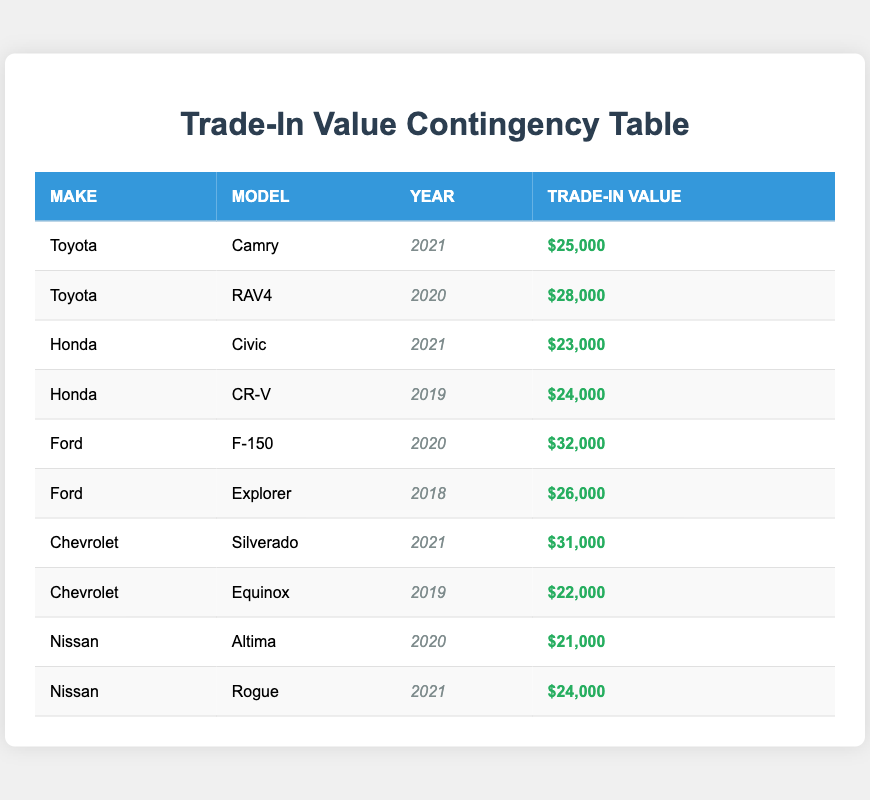What is the trade-in value of the Toyota Camry? Looking at the table, the trade-in value for the Toyota Camry, listed as a 2021 model, is clearly stated as $25,000.
Answer: $25,000 Which vehicle has the highest trade-in value? The table lists the trade-in values of various vehicles; the highest value is for the Ford F-150 at $32,000.
Answer: Ford F-150 What is the trade-in value difference between the Honda Civic and the Honda CR-V? The trade-in value of the Honda Civic is $23,000, while the Honda CR-V is $24,000. The difference is $24,000 - $23,000, which equals $1,000.
Answer: $1,000 Is the trade-in value of the Chevrolet Equinox greater than $20,000? The table shows that the trade-in value of the Chevrolet Equinox is $22,000, which is indeed greater than $20,000, confirming the statement is true.
Answer: Yes What is the average trade-in value for the vehicles listed for Toyota? There are two Toyotas in the table: the Camry ($25,000) and the RAV4 ($28,000). The average can be calculated as (25,000 + 28,000) / 2 = 26,500.
Answer: $26,500 Which vehicle make has a model with a trade-in value of $21,000? The table indicates that the Nissan Altima has a trade-in value of $21,000, confirming that Nissan makes a vehicle with this value.
Answer: Nissan How many models from Ford are listed, and what are their trade-in values? The table presents two Ford models: the F-150 ($32,000) and the Explorer ($26,000), making a total of two models.
Answer: 2 models; F-150: $32,000, Explorer: $26,000 If I add the trade-in value of the Honda CR-V and Chevrolet Silverado, what is the total? The Honda CR-V has a trade-in value of $24,000, and the Chevrolet Silverado has a trade-in value of $31,000. The total is $24,000 + $31,000 = $55,000.
Answer: $55,000 Which vehicle make has the lowest trade-in value, and what is that value? Inspecting the table, the lowest trade-in value is for the Nissan Altima at $21,000, making Nissan the make with the lowest value.
Answer: Nissan; $21,000 